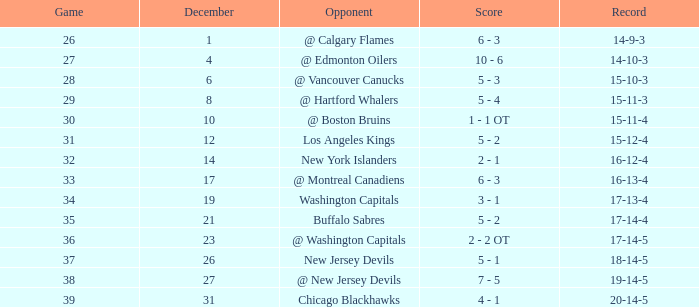Game smaller than 34, and a December smaller than 14, and a Score of 10 - 6 has what opponent? @ Edmonton Oilers. 